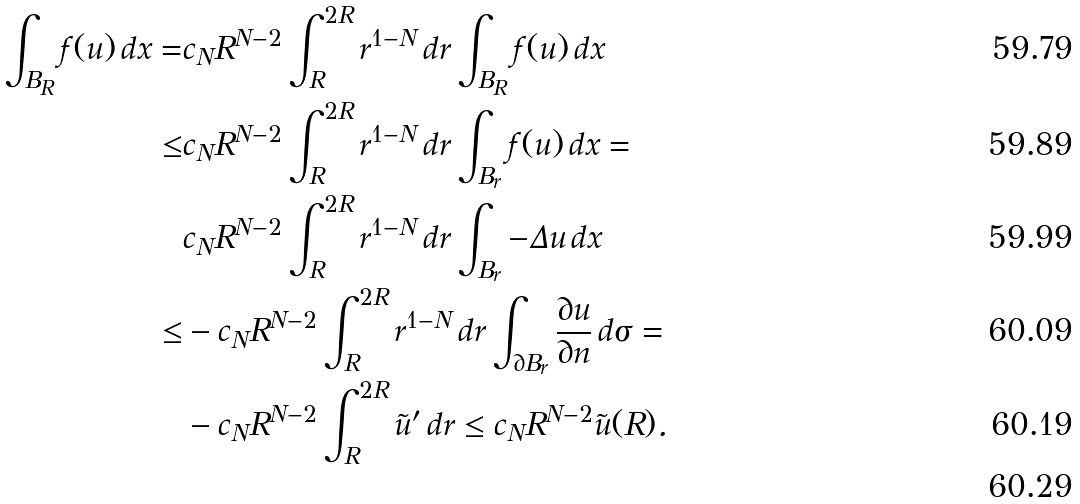<formula> <loc_0><loc_0><loc_500><loc_500>\int _ { B _ { R } } f ( u ) \, d x = & c _ { N } R ^ { N - 2 } \int _ { R } ^ { 2 R } r ^ { 1 - N } \, d r \int _ { B _ { R } } f ( u ) \, d x \\ \leq & c _ { N } R ^ { N - 2 } \int _ { R } ^ { 2 R } r ^ { 1 - N } \, d r \int _ { B _ { r } } f ( u ) \, d x = \\ & c _ { N } R ^ { N - 2 } \int _ { R } ^ { 2 R } r ^ { 1 - N } \, d r \int _ { B _ { r } } - \Delta u \, d x \\ \leq & - c _ { N } R ^ { N - 2 } \int _ { R } ^ { 2 R } r ^ { 1 - N } \, d r \int _ { \partial B _ { r } } \frac { \partial u } { \partial n } \, d \sigma = \\ & - c _ { N } R ^ { N - 2 } \int _ { R } ^ { 2 R } \tilde { u } ^ { \prime } \, d r \leq c _ { N } R ^ { N - 2 } \tilde { u } ( R ) . \\</formula> 